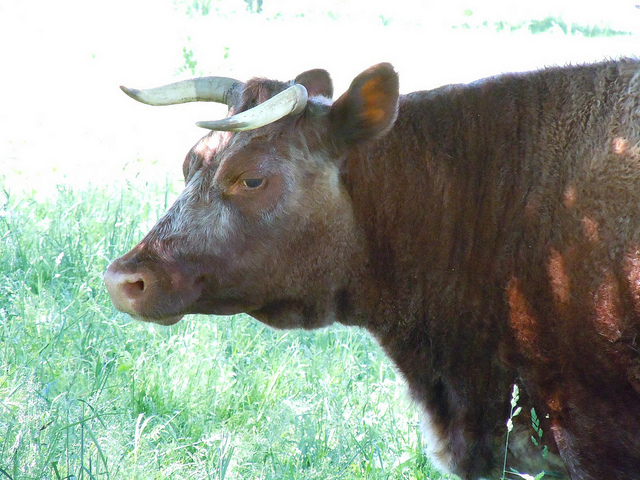How does this animal's unique horn structure benefit it? The long, extended horns of the Longhorn serve several purposes. They provide a formidable defense mechanism against predators and can also be used to establish dominance within the herd. Moreover, the horn's large surface area helps to dissipate heat, which is advantageous in the hotter climates where Longhorns commonly reside. 